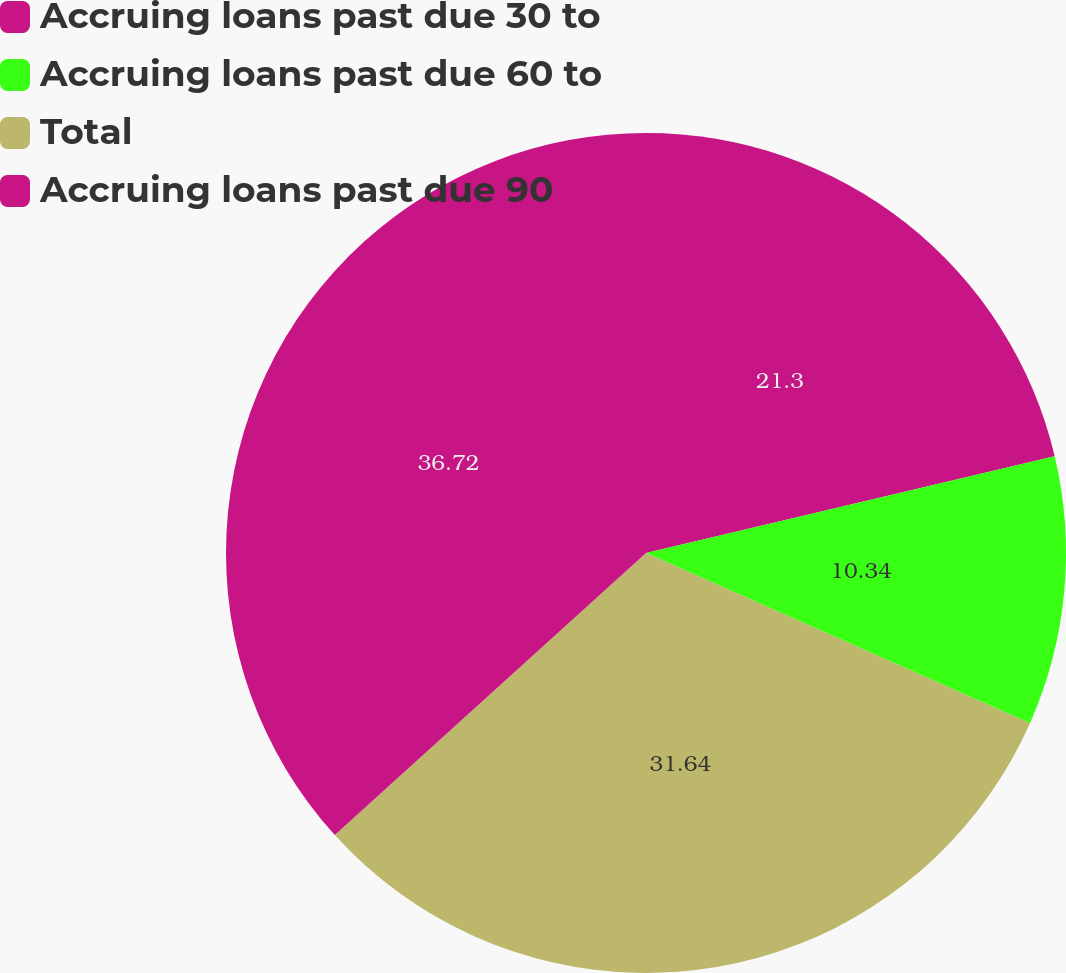<chart> <loc_0><loc_0><loc_500><loc_500><pie_chart><fcel>Accruing loans past due 30 to<fcel>Accruing loans past due 60 to<fcel>Total<fcel>Accruing loans past due 90<nl><fcel>21.3%<fcel>10.34%<fcel>31.64%<fcel>36.72%<nl></chart> 